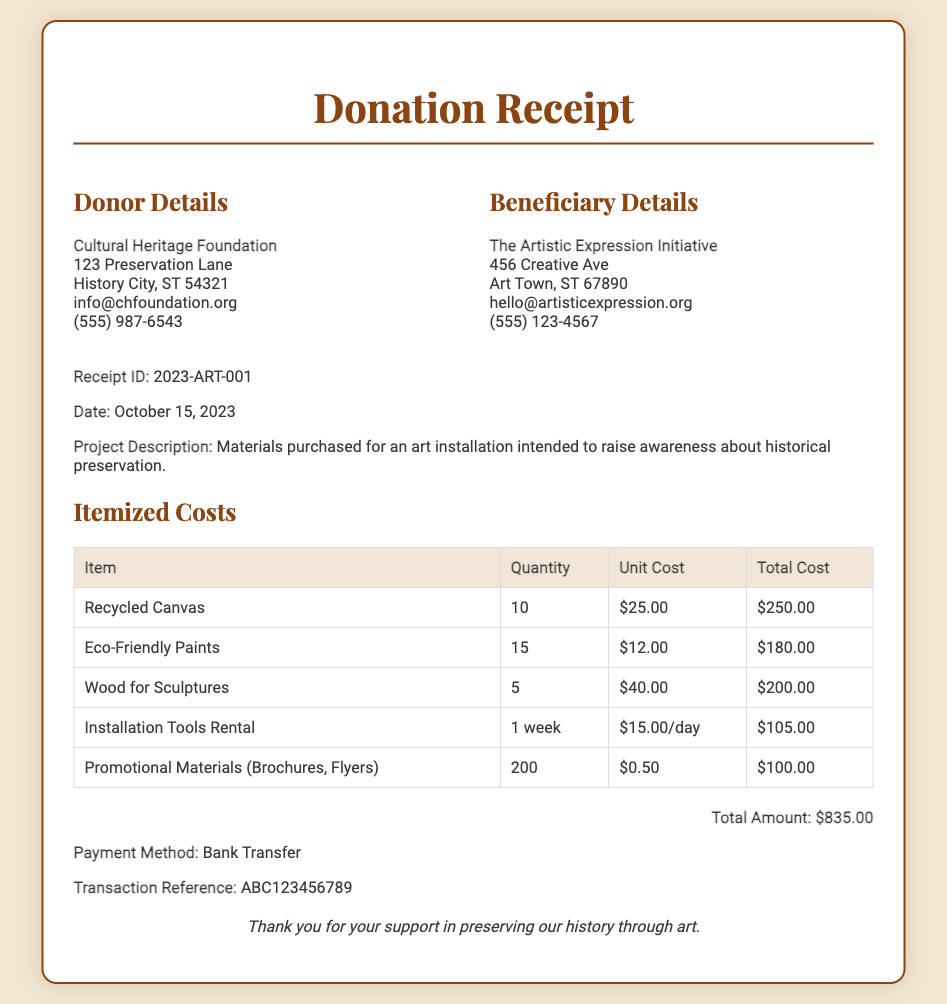what is the receipt ID? The receipt ID is provided in the details section of the document.
Answer: 2023-ART-001 what is the total amount? The total amount is stated at the end of the itemized costs section.
Answer: $835.00 who is the donor? The donor's information is included in the details section.
Answer: Cultural Heritage Foundation what date was the receipt issued? The date can be found in the details section of the document.
Answer: October 15, 2023 how many units of eco-friendly paints were purchased? The quantity of eco-friendly paints is listed in the itemized costs table.
Answer: 15 what method of payment was used? The payment method is specified towards the end of the document.
Answer: Bank Transfer which organization benefited from the donation? The beneficiary details state the organization that received the donation.
Answer: The Artistic Expression Initiative what is one of the items included in the donation? The itemized costs table lists various items purchased for the project.
Answer: Recycled Canvas how much did the installation tools rental cost in total? The total cost is calculated in the itemized costs table for the installation tools rental.
Answer: $105.00 